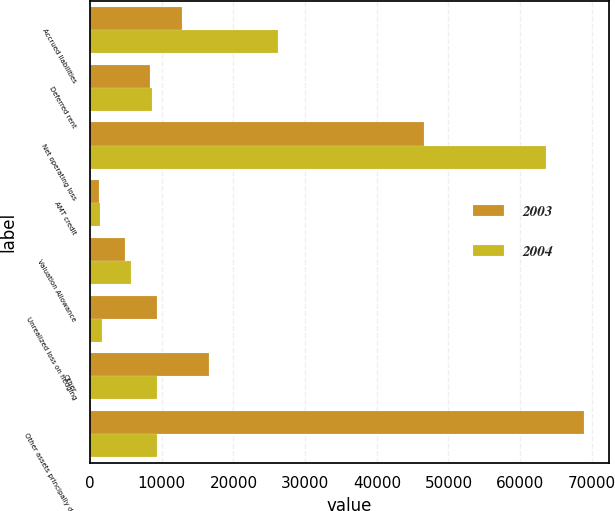<chart> <loc_0><loc_0><loc_500><loc_500><stacked_bar_chart><ecel><fcel>Accrued liabilities<fcel>Deferred rent<fcel>Net operating loss<fcel>AMT credit<fcel>Valuation Allowance<fcel>Unrealized loss on hedging<fcel>Other<fcel>Other assets principally due<nl><fcel>2003<fcel>12854<fcel>8399<fcel>46611<fcel>1187<fcel>4829<fcel>9332<fcel>16589<fcel>68956<nl><fcel>2004<fcel>26181<fcel>8654<fcel>63579<fcel>1364<fcel>5691<fcel>1585<fcel>9278<fcel>9278<nl></chart> 